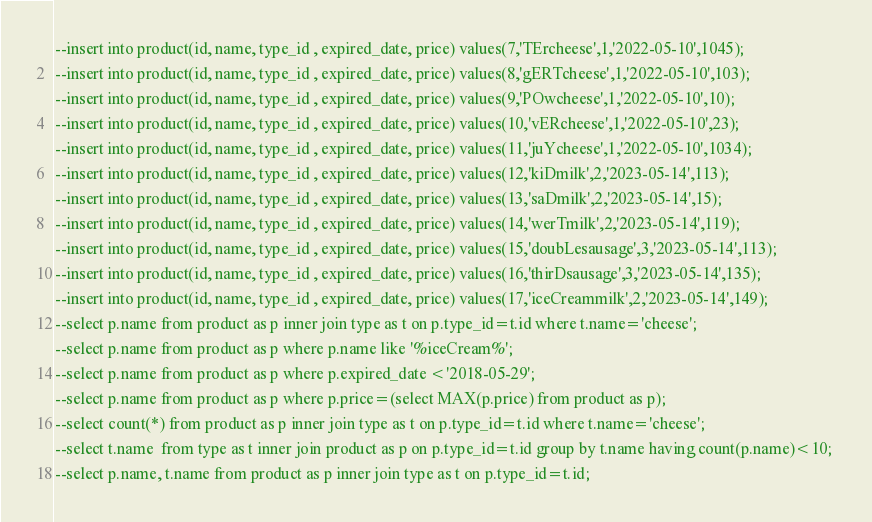Convert code to text. <code><loc_0><loc_0><loc_500><loc_500><_SQL_>--insert into product(id, name, type_id , expired_date, price) values(7,'TErcheese',1,'2022-05-10',1045);
--insert into product(id, name, type_id , expired_date, price) values(8,'gERTcheese',1,'2022-05-10',103);
--insert into product(id, name, type_id , expired_date, price) values(9,'POwcheese',1,'2022-05-10',10);
--insert into product(id, name, type_id , expired_date, price) values(10,'vERcheese',1,'2022-05-10',23);
--insert into product(id, name, type_id , expired_date, price) values(11,'juYcheese',1,'2022-05-10',1034);
--insert into product(id, name, type_id , expired_date, price) values(12,'kiDmilk',2,'2023-05-14',113);
--insert into product(id, name, type_id , expired_date, price) values(13,'saDmilk',2,'2023-05-14',15);
--insert into product(id, name, type_id , expired_date, price) values(14,'werTmilk',2,'2023-05-14',119);
--insert into product(id, name, type_id , expired_date, price) values(15,'doubLesausage',3,'2023-05-14',113);
--insert into product(id, name, type_id , expired_date, price) values(16,'thirDsausage',3,'2023-05-14',135);
--insert into product(id, name, type_id , expired_date, price) values(17,'iceCreammilk',2,'2023-05-14',149);
--select p.name from product as p inner join type as t on p.type_id=t.id where t.name='cheese'; 
--select p.name from product as p where p.name like '%iceCream%';
--select p.name from product as p where p.expired_date <'2018-05-29';
--select p.name from product as p where p.price=(select MAX(p.price) from product as p); 
--select count(*) from product as p inner join type as t on p.type_id=t.id where t.name='cheese';
--select t.name  from type as t inner join product as p on p.type_id=t.id group by t.name having count(p.name)<10; 
--select p.name, t.name from product as p inner join type as t on p.type_id=t.id;


</code> 